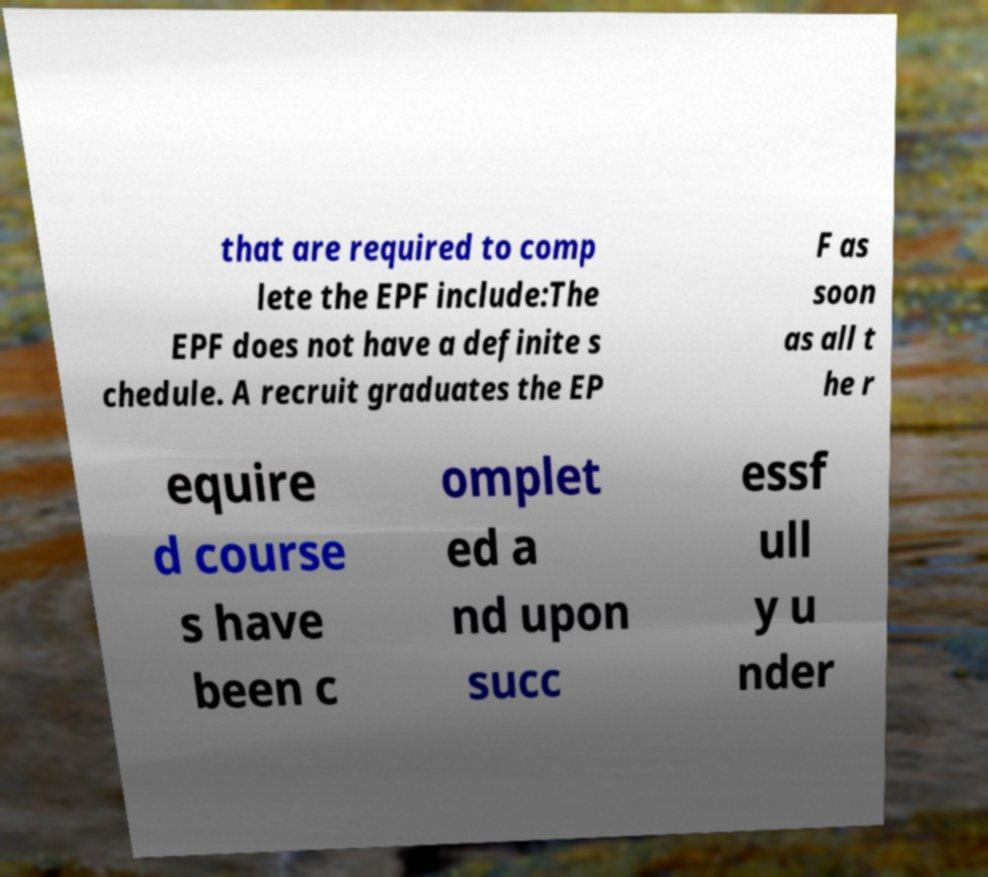Please identify and transcribe the text found in this image. that are required to comp lete the EPF include:The EPF does not have a definite s chedule. A recruit graduates the EP F as soon as all t he r equire d course s have been c omplet ed a nd upon succ essf ull y u nder 